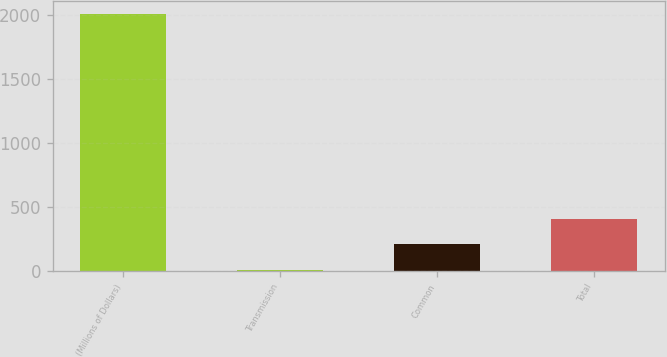Convert chart to OTSL. <chart><loc_0><loc_0><loc_500><loc_500><bar_chart><fcel>(Millions of Dollars)<fcel>Transmission<fcel>Common<fcel>Total<nl><fcel>2007<fcel>6<fcel>206.1<fcel>406.2<nl></chart> 